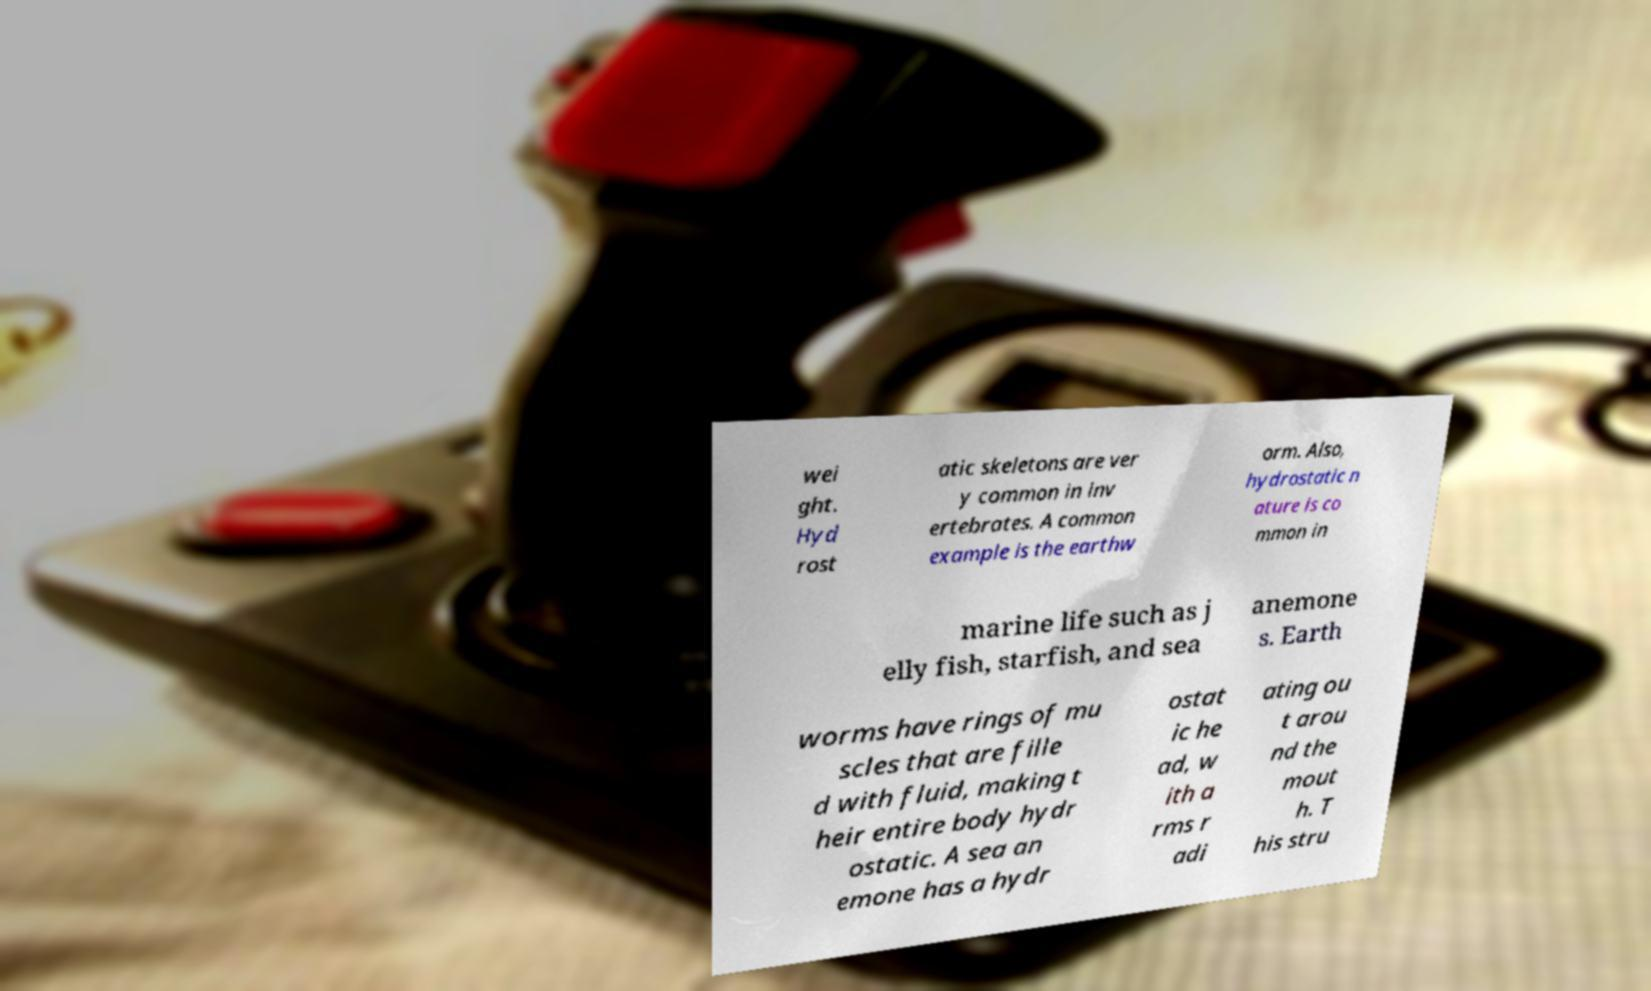Please read and relay the text visible in this image. What does it say? wei ght. Hyd rost atic skeletons are ver y common in inv ertebrates. A common example is the earthw orm. Also, hydrostatic n ature is co mmon in marine life such as j elly fish, starfish, and sea anemone s. Earth worms have rings of mu scles that are fille d with fluid, making t heir entire body hydr ostatic. A sea an emone has a hydr ostat ic he ad, w ith a rms r adi ating ou t arou nd the mout h. T his stru 